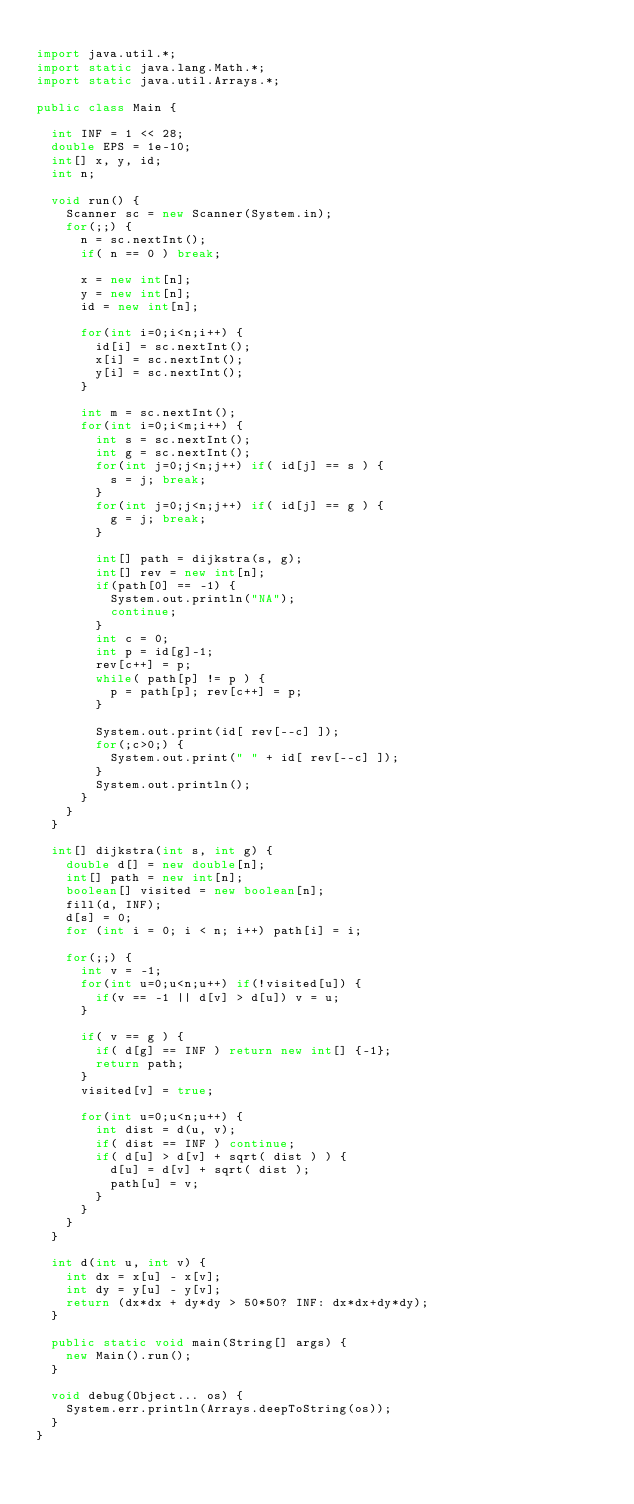<code> <loc_0><loc_0><loc_500><loc_500><_Java_>
import java.util.*;
import static java.lang.Math.*;
import static java.util.Arrays.*;

public class Main {

	int INF = 1 << 28;
	double EPS = 1e-10;
	int[] x, y, id;
	int n;
	
	void run() {
		Scanner sc = new Scanner(System.in);
		for(;;) {
			n = sc.nextInt();
			if( n == 0 ) break;
			
			x = new int[n];
			y = new int[n];
			id = new int[n];
			
			for(int i=0;i<n;i++) {
				id[i] = sc.nextInt();
				x[i] = sc.nextInt();
				y[i] = sc.nextInt();
			}
			
			int m = sc.nextInt();
			for(int i=0;i<m;i++) {
				int s = sc.nextInt();
				int g = sc.nextInt();
				for(int j=0;j<n;j++) if( id[j] == s ) {
					s = j; break;
				}
				for(int j=0;j<n;j++) if( id[j] == g ) {
					g = j; break;
				}

				int[] path = dijkstra(s, g);
				int[] rev = new int[n];
				if(path[0] == -1) {
					System.out.println("NA");
					continue;
				}
				int c = 0;
				int p = id[g]-1;
				rev[c++] = p;
				while( path[p] != p ) {
					p = path[p]; rev[c++] = p;
				}

				System.out.print(id[ rev[--c] ]);
				for(;c>0;) {
					System.out.print(" " + id[ rev[--c] ]);
				}
				System.out.println();
			}
		}
	}
	
	int[] dijkstra(int s, int g) {
		double d[] = new double[n];
		int[] path = new int[n];
		boolean[] visited = new boolean[n];
		fill(d, INF);
		d[s] = 0;
		for (int i = 0; i < n; i++) path[i] = i;
		
		for(;;) {
			int v = -1;
			for(int u=0;u<n;u++) if(!visited[u]) {
				if(v == -1 || d[v] > d[u]) v = u;
			}
			
			if( v == g ) {
				if( d[g] == INF ) return new int[] {-1};
				return path;
			}
			visited[v] = true;
			
			for(int u=0;u<n;u++) {
				int dist = d(u, v);
				if( dist == INF ) continue;
				if( d[u] > d[v] + sqrt( dist ) ) {
					d[u] = d[v] + sqrt( dist );
					path[u] = v;
				}
			}
		}
	}
	
	int d(int u, int v) {
		int dx = x[u] - x[v];
		int dy = y[u] - y[v];
		return (dx*dx + dy*dy > 50*50? INF: dx*dx+dy*dy);
	}

	public static void main(String[] args) {
		new Main().run();
	}

	void debug(Object... os) {
		System.err.println(Arrays.deepToString(os));
	}
}</code> 